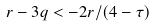<formula> <loc_0><loc_0><loc_500><loc_500>r - 3 q < - 2 r / ( 4 - \tau )</formula> 